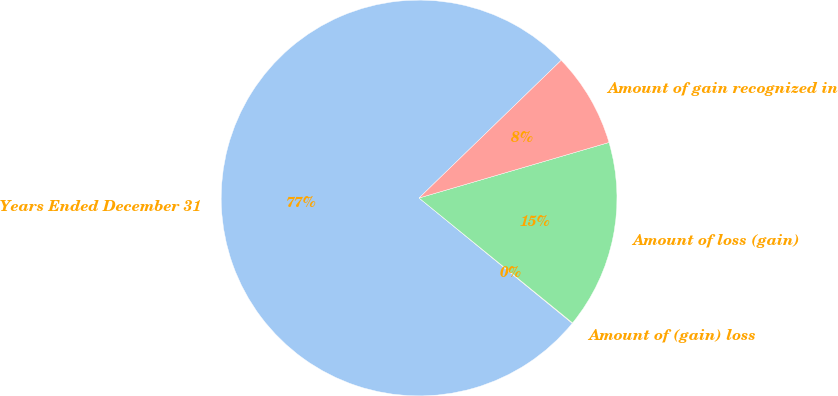<chart> <loc_0><loc_0><loc_500><loc_500><pie_chart><fcel>Years Ended December 31<fcel>Amount of (gain) loss<fcel>Amount of loss (gain)<fcel>Amount of gain recognized in<nl><fcel>76.84%<fcel>0.04%<fcel>15.4%<fcel>7.72%<nl></chart> 